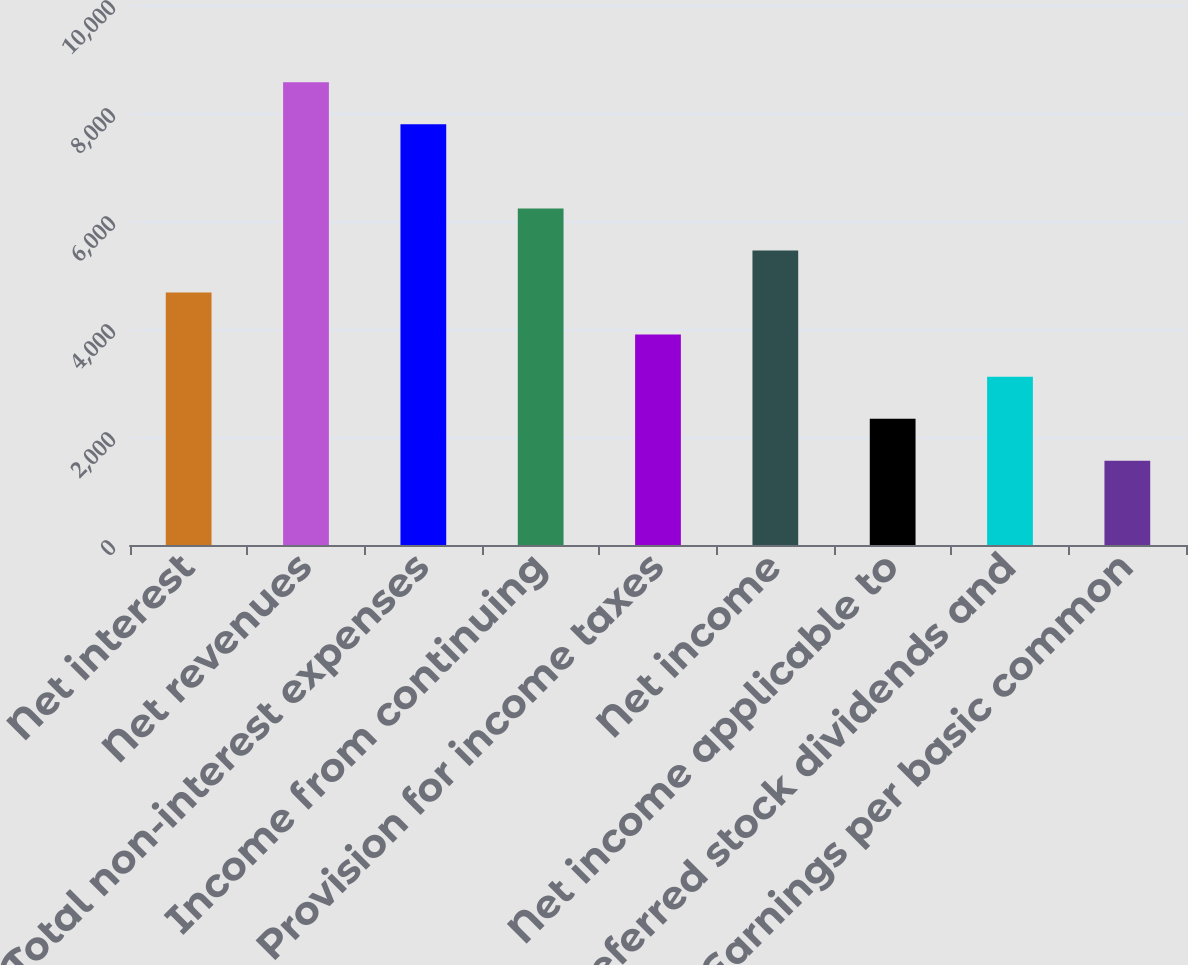<chart> <loc_0><loc_0><loc_500><loc_500><bar_chart><fcel>Net interest<fcel>Net revenues<fcel>Total non-interest expenses<fcel>Income from continuing<fcel>Provision for income taxes<fcel>Net income<fcel>Net income applicable to<fcel>Preferred stock dividends and<fcel>Earnings per basic common<nl><fcel>4675.28<fcel>8571.23<fcel>7792.04<fcel>6233.66<fcel>3896.09<fcel>5454.47<fcel>2337.72<fcel>3116.9<fcel>1558.53<nl></chart> 